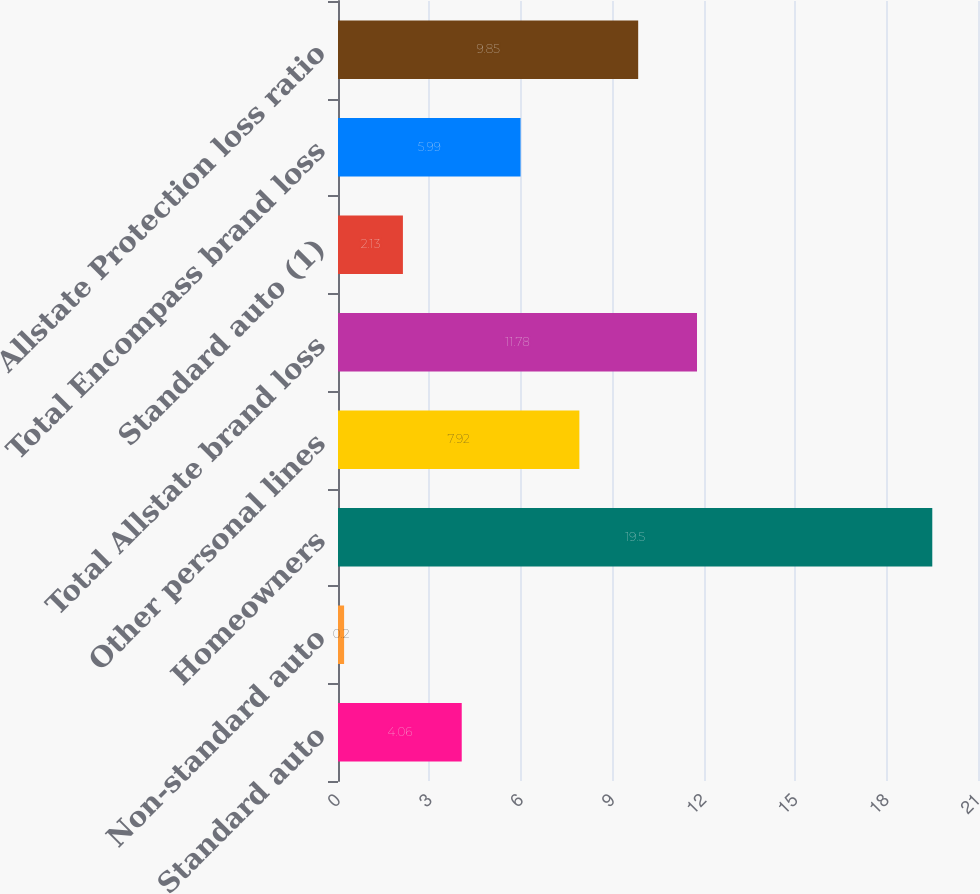<chart> <loc_0><loc_0><loc_500><loc_500><bar_chart><fcel>Standard auto<fcel>Non-standard auto<fcel>Homeowners<fcel>Other personal lines<fcel>Total Allstate brand loss<fcel>Standard auto (1)<fcel>Total Encompass brand loss<fcel>Allstate Protection loss ratio<nl><fcel>4.06<fcel>0.2<fcel>19.5<fcel>7.92<fcel>11.78<fcel>2.13<fcel>5.99<fcel>9.85<nl></chart> 